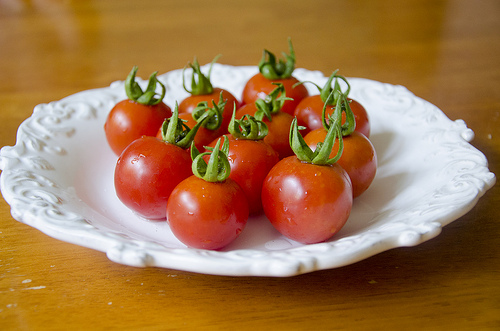<image>
Is the tomato behind the droplet? No. The tomato is not behind the droplet. From this viewpoint, the tomato appears to be positioned elsewhere in the scene. Where is the tomato in relation to the table? Is it behind the table? No. The tomato is not behind the table. From this viewpoint, the tomato appears to be positioned elsewhere in the scene. 